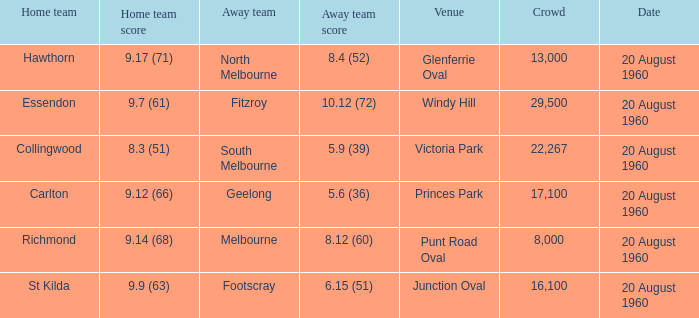What is the venue when Geelong is the away team? Princes Park. 